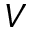Convert formula to latex. <formula><loc_0><loc_0><loc_500><loc_500>V</formula> 